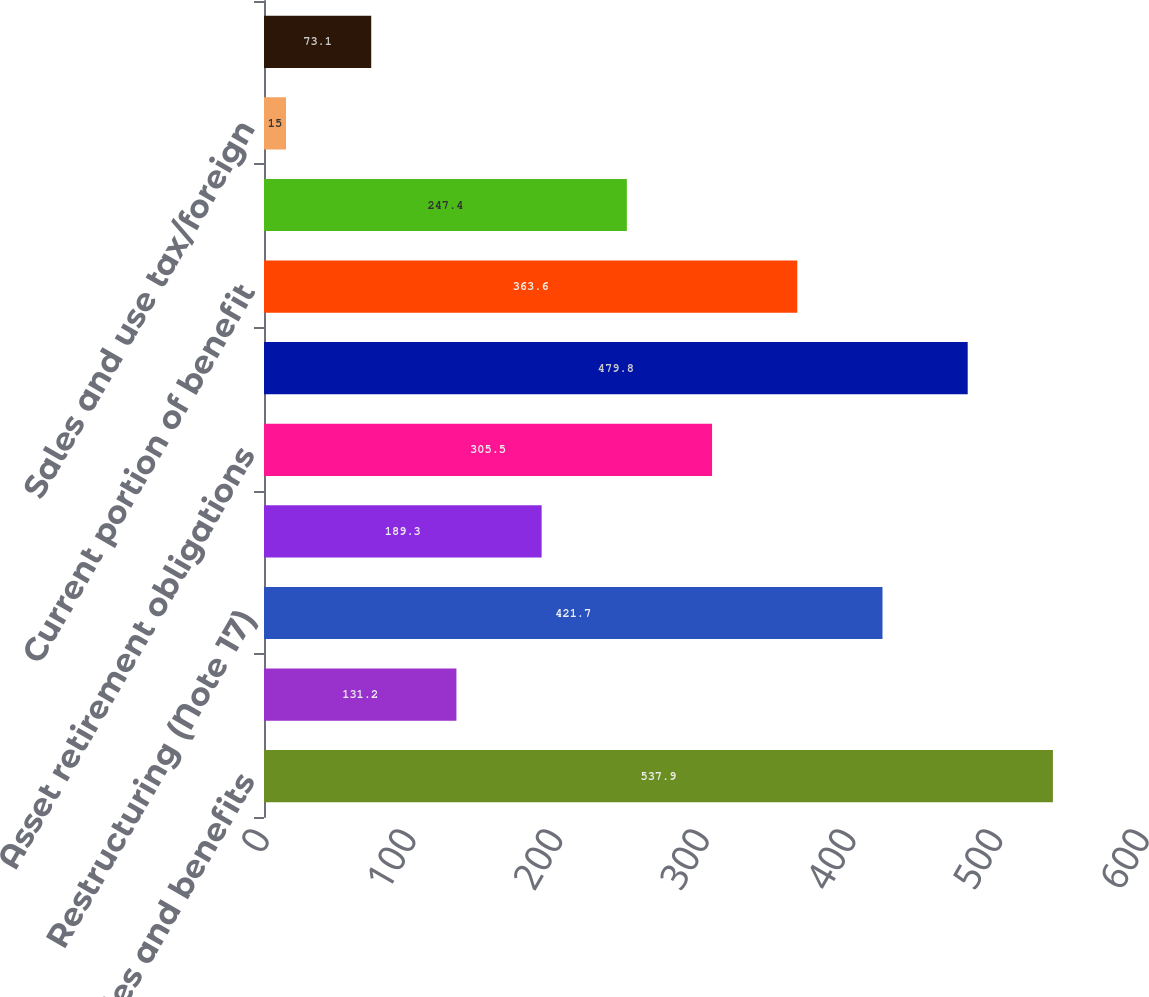Convert chart to OTSL. <chart><loc_0><loc_0><loc_500><loc_500><bar_chart><fcel>Salaries and benefits<fcel>Environmental (Note 15)<fcel>Restructuring (Note 17)<fcel>Insurance<fcel>Asset retirement obligations<fcel>Derivatives (Note 21)<fcel>Current portion of benefit<fcel>Interest<fcel>Sales and use tax/foreign<fcel>Uncertain tax positions (Note<nl><fcel>537.9<fcel>131.2<fcel>421.7<fcel>189.3<fcel>305.5<fcel>479.8<fcel>363.6<fcel>247.4<fcel>15<fcel>73.1<nl></chart> 